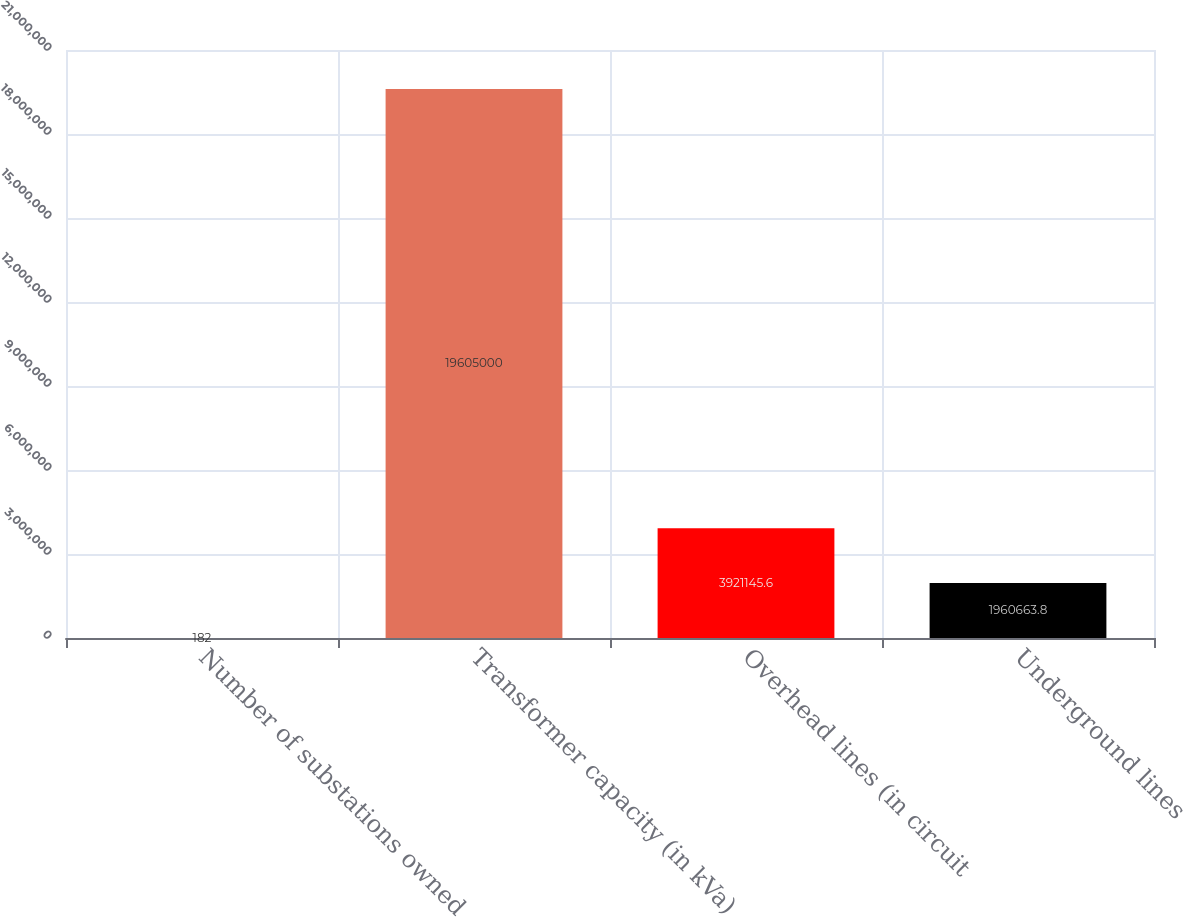Convert chart. <chart><loc_0><loc_0><loc_500><loc_500><bar_chart><fcel>Number of substations owned<fcel>Transformer capacity (in kVa)<fcel>Overhead lines (in circuit<fcel>Underground lines<nl><fcel>182<fcel>1.9605e+07<fcel>3.92115e+06<fcel>1.96066e+06<nl></chart> 